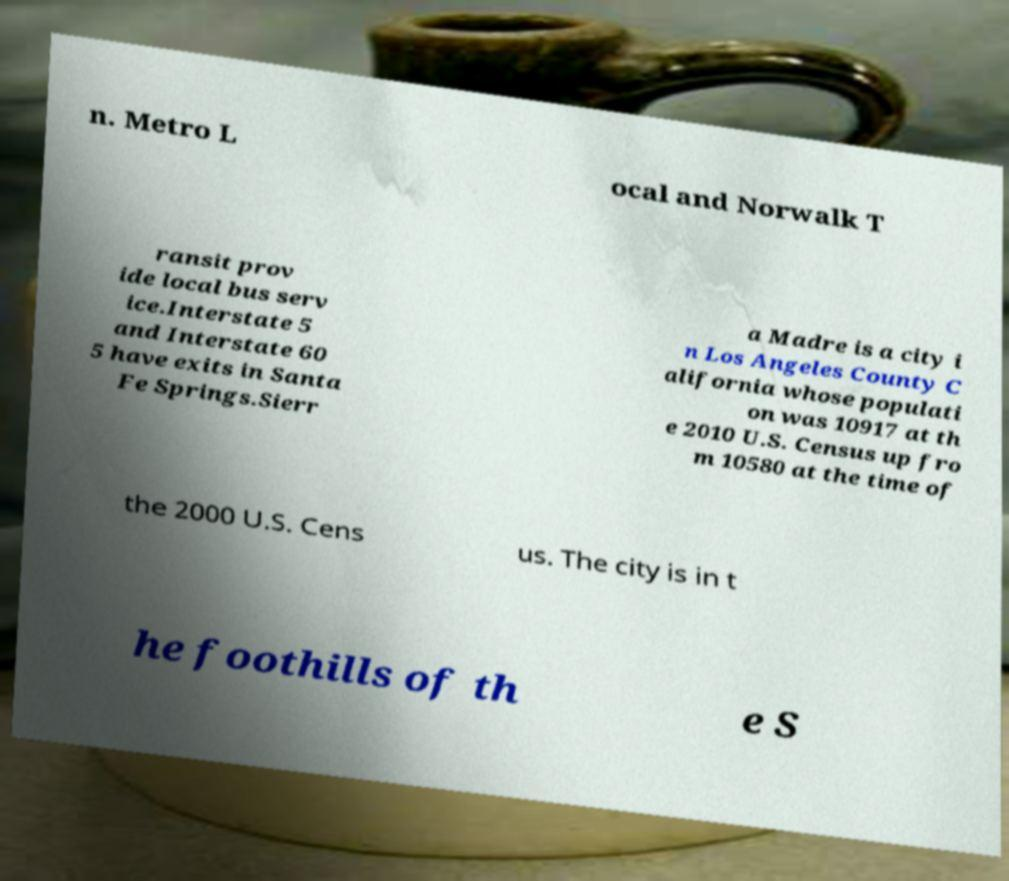I need the written content from this picture converted into text. Can you do that? n. Metro L ocal and Norwalk T ransit prov ide local bus serv ice.Interstate 5 and Interstate 60 5 have exits in Santa Fe Springs.Sierr a Madre is a city i n Los Angeles County C alifornia whose populati on was 10917 at th e 2010 U.S. Census up fro m 10580 at the time of the 2000 U.S. Cens us. The city is in t he foothills of th e S 